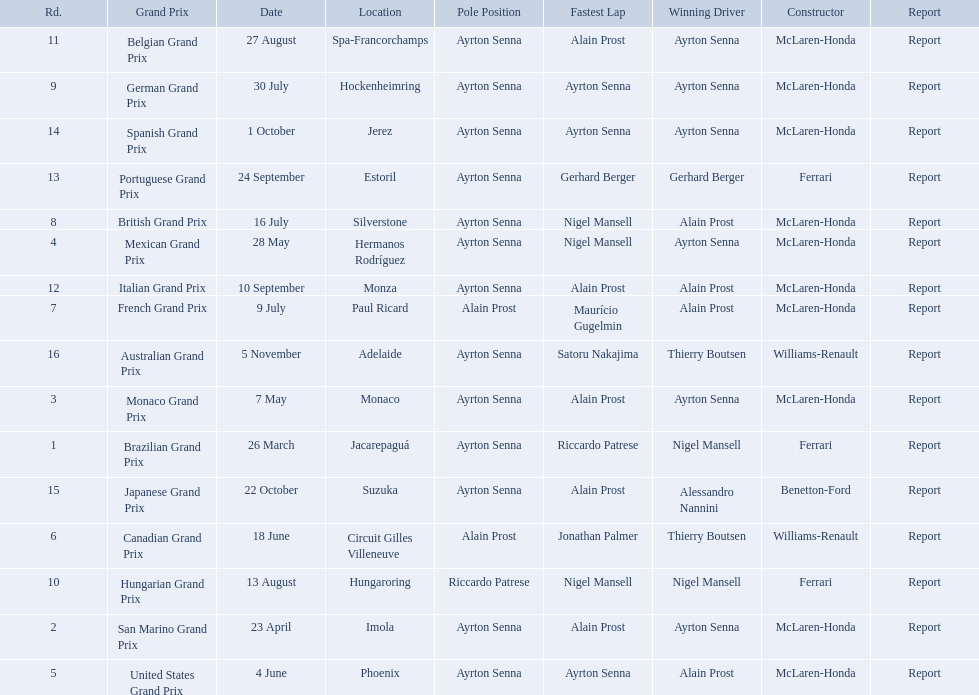Who won the spanish grand prix? McLaren-Honda. Who won the italian grand prix? McLaren-Honda. I'm looking to parse the entire table for insights. Could you assist me with that? {'header': ['Rd.', 'Grand Prix', 'Date', 'Location', 'Pole Position', 'Fastest Lap', 'Winning Driver', 'Constructor', 'Report'], 'rows': [['11', 'Belgian Grand Prix', '27 August', 'Spa-Francorchamps', 'Ayrton Senna', 'Alain Prost', 'Ayrton Senna', 'McLaren-Honda', 'Report'], ['9', 'German Grand Prix', '30 July', 'Hockenheimring', 'Ayrton Senna', 'Ayrton Senna', 'Ayrton Senna', 'McLaren-Honda', 'Report'], ['14', 'Spanish Grand Prix', '1 October', 'Jerez', 'Ayrton Senna', 'Ayrton Senna', 'Ayrton Senna', 'McLaren-Honda', 'Report'], ['13', 'Portuguese Grand Prix', '24 September', 'Estoril', 'Ayrton Senna', 'Gerhard Berger', 'Gerhard Berger', 'Ferrari', 'Report'], ['8', 'British Grand Prix', '16 July', 'Silverstone', 'Ayrton Senna', 'Nigel Mansell', 'Alain Prost', 'McLaren-Honda', 'Report'], ['4', 'Mexican Grand Prix', '28 May', 'Hermanos Rodríguez', 'Ayrton Senna', 'Nigel Mansell', 'Ayrton Senna', 'McLaren-Honda', 'Report'], ['12', 'Italian Grand Prix', '10 September', 'Monza', 'Ayrton Senna', 'Alain Prost', 'Alain Prost', 'McLaren-Honda', 'Report'], ['7', 'French Grand Prix', '9 July', 'Paul Ricard', 'Alain Prost', 'Maurício Gugelmin', 'Alain Prost', 'McLaren-Honda', 'Report'], ['16', 'Australian Grand Prix', '5 November', 'Adelaide', 'Ayrton Senna', 'Satoru Nakajima', 'Thierry Boutsen', 'Williams-Renault', 'Report'], ['3', 'Monaco Grand Prix', '7 May', 'Monaco', 'Ayrton Senna', 'Alain Prost', 'Ayrton Senna', 'McLaren-Honda', 'Report'], ['1', 'Brazilian Grand Prix', '26 March', 'Jacarepaguá', 'Ayrton Senna', 'Riccardo Patrese', 'Nigel Mansell', 'Ferrari', 'Report'], ['15', 'Japanese Grand Prix', '22 October', 'Suzuka', 'Ayrton Senna', 'Alain Prost', 'Alessandro Nannini', 'Benetton-Ford', 'Report'], ['6', 'Canadian Grand Prix', '18 June', 'Circuit Gilles Villeneuve', 'Alain Prost', 'Jonathan Palmer', 'Thierry Boutsen', 'Williams-Renault', 'Report'], ['10', 'Hungarian Grand Prix', '13 August', 'Hungaroring', 'Riccardo Patrese', 'Nigel Mansell', 'Nigel Mansell', 'Ferrari', 'Report'], ['2', 'San Marino Grand Prix', '23 April', 'Imola', 'Ayrton Senna', 'Alain Prost', 'Ayrton Senna', 'McLaren-Honda', 'Report'], ['5', 'United States Grand Prix', '4 June', 'Phoenix', 'Ayrton Senna', 'Ayrton Senna', 'Alain Prost', 'McLaren-Honda', 'Report']]} What grand prix did benneton-ford win? Japanese Grand Prix. 